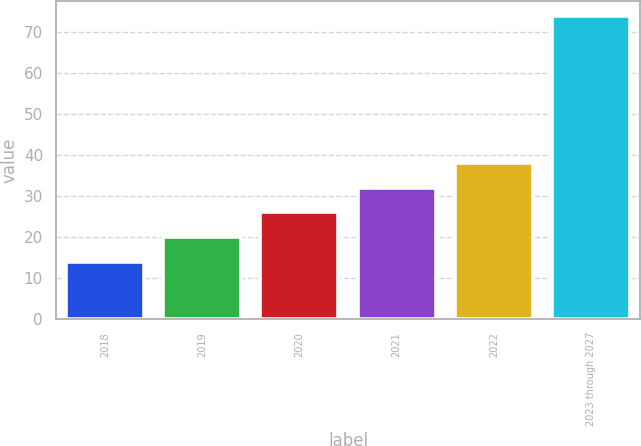Convert chart to OTSL. <chart><loc_0><loc_0><loc_500><loc_500><bar_chart><fcel>2018<fcel>2019<fcel>2020<fcel>2021<fcel>2022<fcel>2023 through 2027<nl><fcel>14<fcel>20<fcel>26<fcel>32<fcel>38<fcel>74<nl></chart> 